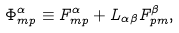Convert formula to latex. <formula><loc_0><loc_0><loc_500><loc_500>\Phi _ { m p } ^ { \alpha } \equiv F _ { m p } ^ { \alpha } + L _ { \alpha \beta } F _ { p m } ^ { \beta } ,</formula> 